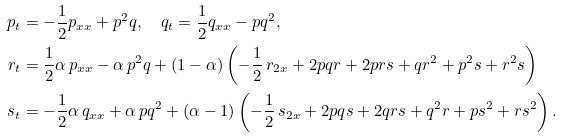Convert formula to latex. <formula><loc_0><loc_0><loc_500><loc_500>p _ { t } & = - \frac { 1 } { 2 } p _ { x x } + p ^ { 2 } q , \quad q _ { t } = \frac { 1 } { 2 } q _ { x x } - p q ^ { 2 } , \\ r _ { t } & = \frac { 1 } { 2 } \alpha \, p _ { x x } - \alpha \, p ^ { 2 } q + ( 1 - \alpha ) \left ( - \frac { 1 } { 2 } \, r _ { 2 x } + 2 p q r + 2 p r s + q r ^ { 2 } + p ^ { 2 } s + r ^ { 2 } s \right ) \\ s _ { t } & = - \frac { 1 } { 2 } \alpha \, q _ { x x } + \alpha \, p q ^ { 2 } + ( \alpha - 1 ) \left ( - \frac { 1 } { 2 } \, s _ { 2 x } + 2 p q s + 2 q r s + q ^ { 2 } r + p s ^ { 2 } + r s ^ { 2 } \right ) .</formula> 